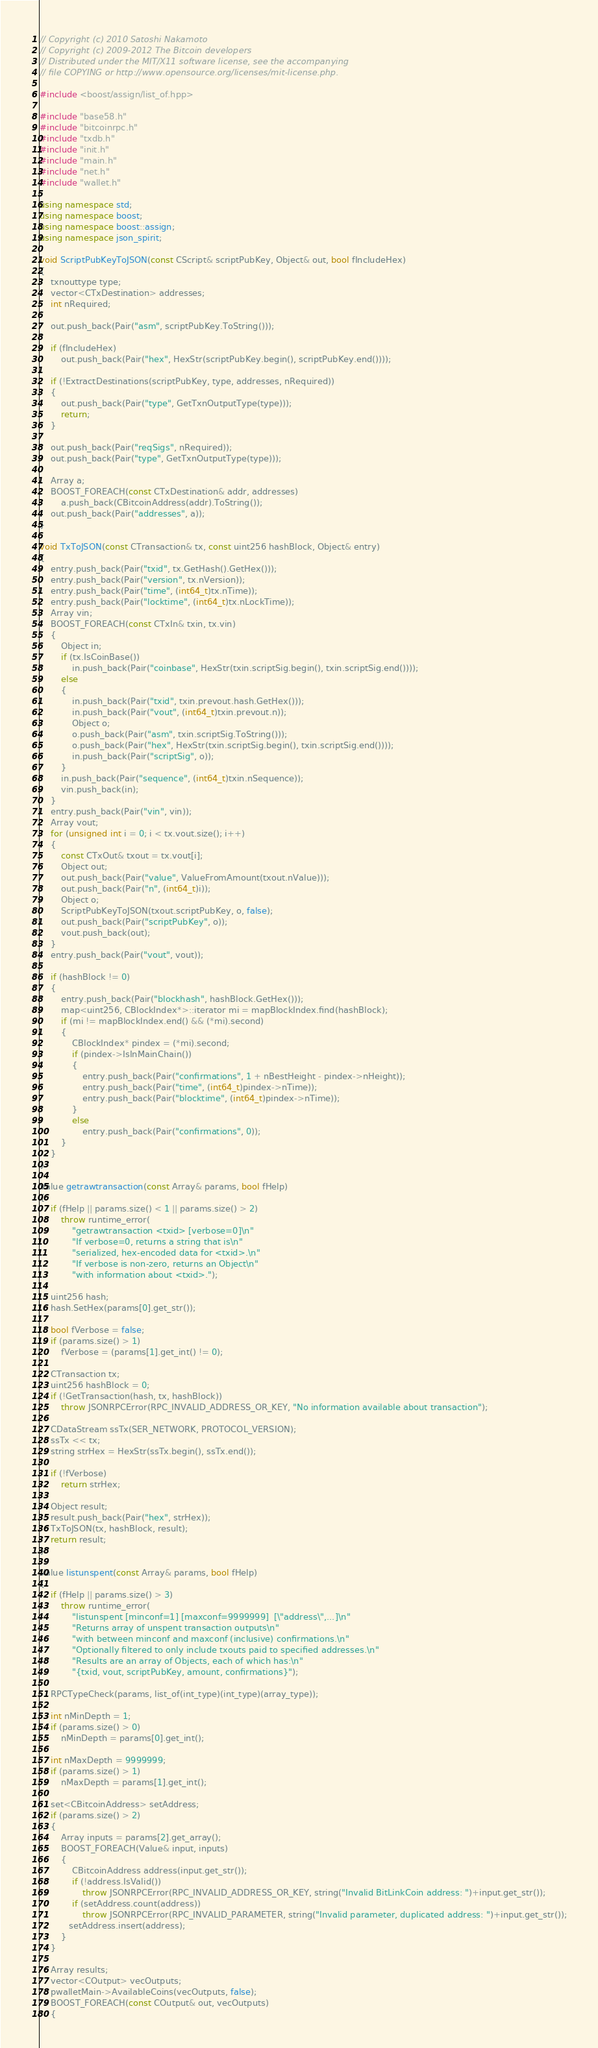<code> <loc_0><loc_0><loc_500><loc_500><_C++_>// Copyright (c) 2010 Satoshi Nakamoto
// Copyright (c) 2009-2012 The Bitcoin developers
// Distributed under the MIT/X11 software license, see the accompanying
// file COPYING or http://www.opensource.org/licenses/mit-license.php.

#include <boost/assign/list_of.hpp>

#include "base58.h"
#include "bitcoinrpc.h"
#include "txdb.h"
#include "init.h"
#include "main.h"
#include "net.h"
#include "wallet.h"

using namespace std;
using namespace boost;
using namespace boost::assign;
using namespace json_spirit;

void ScriptPubKeyToJSON(const CScript& scriptPubKey, Object& out, bool fIncludeHex)
{
    txnouttype type;
    vector<CTxDestination> addresses;
    int nRequired;

    out.push_back(Pair("asm", scriptPubKey.ToString()));

    if (fIncludeHex)
        out.push_back(Pair("hex", HexStr(scriptPubKey.begin(), scriptPubKey.end())));

    if (!ExtractDestinations(scriptPubKey, type, addresses, nRequired))
    {
        out.push_back(Pair("type", GetTxnOutputType(type)));
        return;
    }

    out.push_back(Pair("reqSigs", nRequired));
    out.push_back(Pair("type", GetTxnOutputType(type)));

    Array a;
    BOOST_FOREACH(const CTxDestination& addr, addresses)
        a.push_back(CBitcoinAddress(addr).ToString());
    out.push_back(Pair("addresses", a));
}

void TxToJSON(const CTransaction& tx, const uint256 hashBlock, Object& entry)
{
    entry.push_back(Pair("txid", tx.GetHash().GetHex()));
    entry.push_back(Pair("version", tx.nVersion));
    entry.push_back(Pair("time", (int64_t)tx.nTime));
    entry.push_back(Pair("locktime", (int64_t)tx.nLockTime));
    Array vin;
    BOOST_FOREACH(const CTxIn& txin, tx.vin)
    {
        Object in;
        if (tx.IsCoinBase())
            in.push_back(Pair("coinbase", HexStr(txin.scriptSig.begin(), txin.scriptSig.end())));
        else
        {
            in.push_back(Pair("txid", txin.prevout.hash.GetHex()));
            in.push_back(Pair("vout", (int64_t)txin.prevout.n));
            Object o;
            o.push_back(Pair("asm", txin.scriptSig.ToString()));
            o.push_back(Pair("hex", HexStr(txin.scriptSig.begin(), txin.scriptSig.end())));
            in.push_back(Pair("scriptSig", o));
        }
        in.push_back(Pair("sequence", (int64_t)txin.nSequence));
        vin.push_back(in);
    }
    entry.push_back(Pair("vin", vin));
    Array vout;
    for (unsigned int i = 0; i < tx.vout.size(); i++)
    {
        const CTxOut& txout = tx.vout[i];
        Object out;
        out.push_back(Pair("value", ValueFromAmount(txout.nValue)));
        out.push_back(Pair("n", (int64_t)i));
        Object o;
        ScriptPubKeyToJSON(txout.scriptPubKey, o, false);
        out.push_back(Pair("scriptPubKey", o));
        vout.push_back(out);
    }
    entry.push_back(Pair("vout", vout));

    if (hashBlock != 0)
    {
        entry.push_back(Pair("blockhash", hashBlock.GetHex()));
        map<uint256, CBlockIndex*>::iterator mi = mapBlockIndex.find(hashBlock);
        if (mi != mapBlockIndex.end() && (*mi).second)
        {
            CBlockIndex* pindex = (*mi).second;
            if (pindex->IsInMainChain())
            {
                entry.push_back(Pair("confirmations", 1 + nBestHeight - pindex->nHeight));
                entry.push_back(Pair("time", (int64_t)pindex->nTime));
                entry.push_back(Pair("blocktime", (int64_t)pindex->nTime));
            }
            else
                entry.push_back(Pair("confirmations", 0));
        }
    }
}

Value getrawtransaction(const Array& params, bool fHelp)
{
    if (fHelp || params.size() < 1 || params.size() > 2)
        throw runtime_error(
            "getrawtransaction <txid> [verbose=0]\n"
            "If verbose=0, returns a string that is\n"
            "serialized, hex-encoded data for <txid>.\n"
            "If verbose is non-zero, returns an Object\n"
            "with information about <txid>.");

    uint256 hash;
    hash.SetHex(params[0].get_str());

    bool fVerbose = false;
    if (params.size() > 1)
        fVerbose = (params[1].get_int() != 0);

    CTransaction tx;
    uint256 hashBlock = 0;
    if (!GetTransaction(hash, tx, hashBlock))
        throw JSONRPCError(RPC_INVALID_ADDRESS_OR_KEY, "No information available about transaction");

    CDataStream ssTx(SER_NETWORK, PROTOCOL_VERSION);
    ssTx << tx;
    string strHex = HexStr(ssTx.begin(), ssTx.end());

    if (!fVerbose)
        return strHex;

    Object result;
    result.push_back(Pair("hex", strHex));
    TxToJSON(tx, hashBlock, result);
    return result;
}

Value listunspent(const Array& params, bool fHelp)
{
    if (fHelp || params.size() > 3)
        throw runtime_error(
            "listunspent [minconf=1] [maxconf=9999999]  [\"address\",...]\n"
            "Returns array of unspent transaction outputs\n"
            "with between minconf and maxconf (inclusive) confirmations.\n"
            "Optionally filtered to only include txouts paid to specified addresses.\n"
            "Results are an array of Objects, each of which has:\n"
            "{txid, vout, scriptPubKey, amount, confirmations}");

    RPCTypeCheck(params, list_of(int_type)(int_type)(array_type));

    int nMinDepth = 1;
    if (params.size() > 0)
        nMinDepth = params[0].get_int();

    int nMaxDepth = 9999999;
    if (params.size() > 1)
        nMaxDepth = params[1].get_int();

    set<CBitcoinAddress> setAddress;
    if (params.size() > 2)
    {
        Array inputs = params[2].get_array();
        BOOST_FOREACH(Value& input, inputs)
        {
            CBitcoinAddress address(input.get_str());
            if (!address.IsValid())
                throw JSONRPCError(RPC_INVALID_ADDRESS_OR_KEY, string("Invalid BitLinkCoin address: ")+input.get_str());
            if (setAddress.count(address))
                throw JSONRPCError(RPC_INVALID_PARAMETER, string("Invalid parameter, duplicated address: ")+input.get_str());
           setAddress.insert(address);
        }
    }

    Array results;
    vector<COutput> vecOutputs;
    pwalletMain->AvailableCoins(vecOutputs, false);
    BOOST_FOREACH(const COutput& out, vecOutputs)
    {</code> 